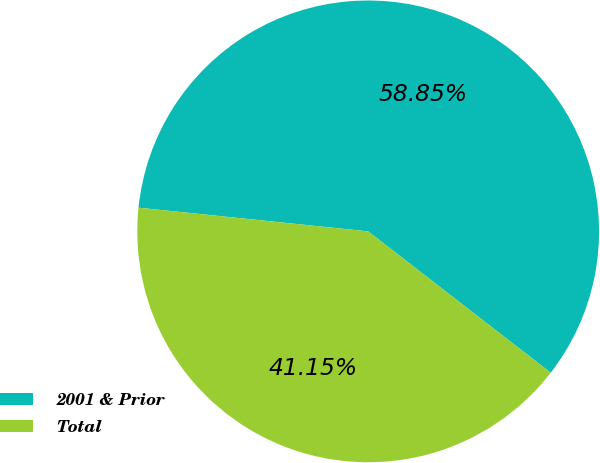<chart> <loc_0><loc_0><loc_500><loc_500><pie_chart><fcel>2001 & Prior<fcel>Total<nl><fcel>58.85%<fcel>41.15%<nl></chart> 